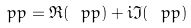<formula> <loc_0><loc_0><loc_500><loc_500>\ p p = \Re ( \ p p ) + i \Im ( \ p p )</formula> 